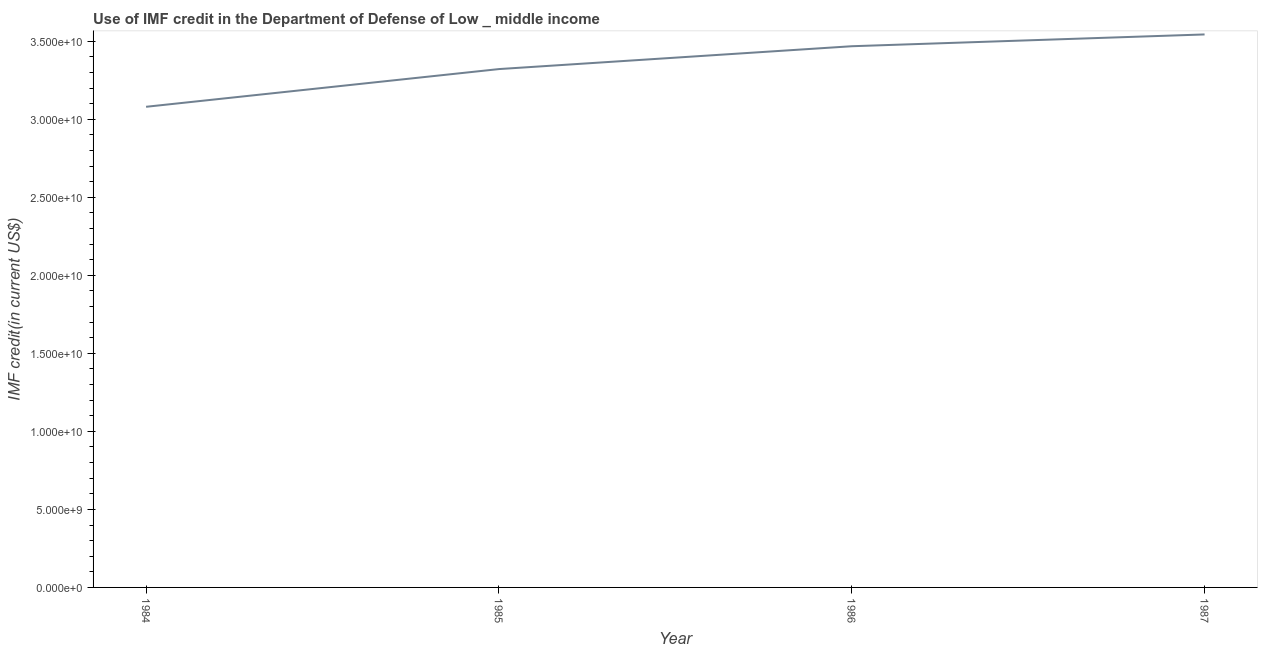What is the use of imf credit in dod in 1985?
Give a very brief answer. 3.32e+1. Across all years, what is the maximum use of imf credit in dod?
Make the answer very short. 3.54e+1. Across all years, what is the minimum use of imf credit in dod?
Your answer should be compact. 3.08e+1. In which year was the use of imf credit in dod maximum?
Offer a terse response. 1987. What is the sum of the use of imf credit in dod?
Give a very brief answer. 1.34e+11. What is the difference between the use of imf credit in dod in 1985 and 1986?
Your answer should be very brief. -1.46e+09. What is the average use of imf credit in dod per year?
Your answer should be very brief. 3.35e+1. What is the median use of imf credit in dod?
Provide a short and direct response. 3.39e+1. What is the ratio of the use of imf credit in dod in 1984 to that in 1985?
Ensure brevity in your answer.  0.93. Is the difference between the use of imf credit in dod in 1985 and 1987 greater than the difference between any two years?
Ensure brevity in your answer.  No. What is the difference between the highest and the second highest use of imf credit in dod?
Keep it short and to the point. 7.56e+08. What is the difference between the highest and the lowest use of imf credit in dod?
Offer a very short reply. 4.64e+09. How many lines are there?
Provide a succinct answer. 1. How many years are there in the graph?
Provide a short and direct response. 4. Does the graph contain any zero values?
Your answer should be very brief. No. Does the graph contain grids?
Offer a very short reply. No. What is the title of the graph?
Provide a short and direct response. Use of IMF credit in the Department of Defense of Low _ middle income. What is the label or title of the Y-axis?
Your answer should be compact. IMF credit(in current US$). What is the IMF credit(in current US$) in 1984?
Your response must be concise. 3.08e+1. What is the IMF credit(in current US$) of 1985?
Keep it short and to the point. 3.32e+1. What is the IMF credit(in current US$) of 1986?
Provide a short and direct response. 3.47e+1. What is the IMF credit(in current US$) in 1987?
Keep it short and to the point. 3.54e+1. What is the difference between the IMF credit(in current US$) in 1984 and 1985?
Provide a succinct answer. -2.42e+09. What is the difference between the IMF credit(in current US$) in 1984 and 1986?
Offer a terse response. -3.88e+09. What is the difference between the IMF credit(in current US$) in 1984 and 1987?
Give a very brief answer. -4.64e+09. What is the difference between the IMF credit(in current US$) in 1985 and 1986?
Keep it short and to the point. -1.46e+09. What is the difference between the IMF credit(in current US$) in 1985 and 1987?
Make the answer very short. -2.22e+09. What is the difference between the IMF credit(in current US$) in 1986 and 1987?
Give a very brief answer. -7.56e+08. What is the ratio of the IMF credit(in current US$) in 1984 to that in 1985?
Ensure brevity in your answer.  0.93. What is the ratio of the IMF credit(in current US$) in 1984 to that in 1986?
Provide a succinct answer. 0.89. What is the ratio of the IMF credit(in current US$) in 1984 to that in 1987?
Give a very brief answer. 0.87. What is the ratio of the IMF credit(in current US$) in 1985 to that in 1986?
Give a very brief answer. 0.96. What is the ratio of the IMF credit(in current US$) in 1985 to that in 1987?
Offer a terse response. 0.94. What is the ratio of the IMF credit(in current US$) in 1986 to that in 1987?
Your answer should be very brief. 0.98. 